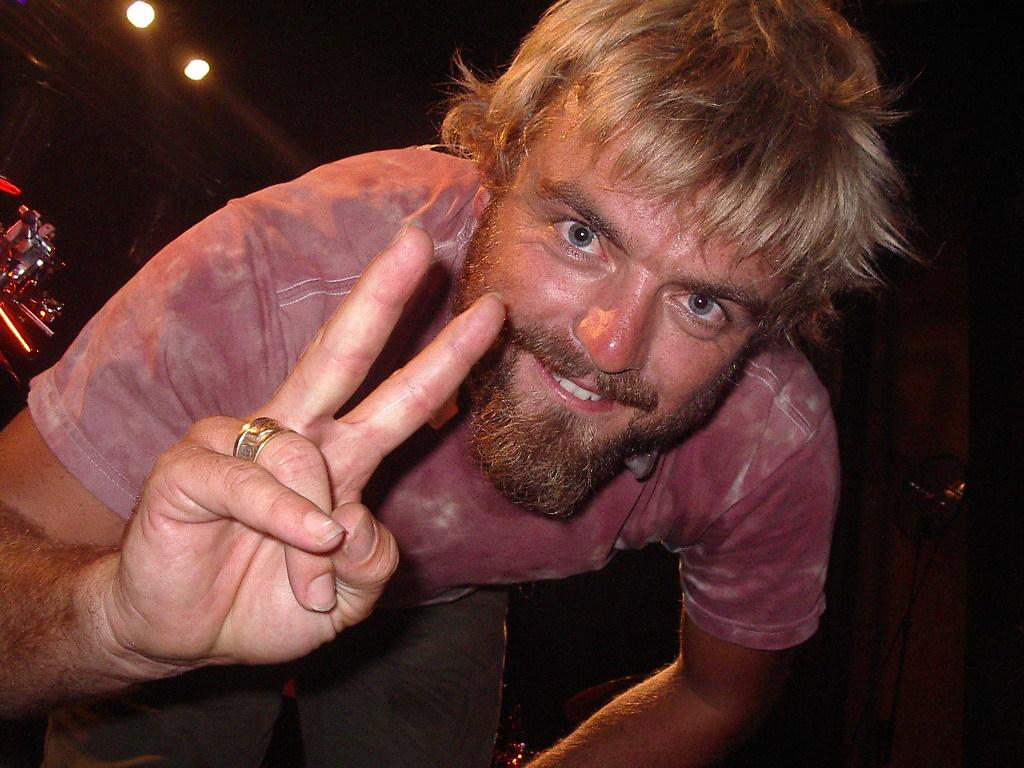Who is in the image? There is a person in the image. What is the person wearing? The person is wearing a pink shirt. What gesture is the person making? The person is showing a V sign. What can be seen in the background of the image? There are lights and other objects in the background of the image. How does the person support the weight of the building in the image? The person is not supporting the weight of a building in the image; they are simply making a V sign. 